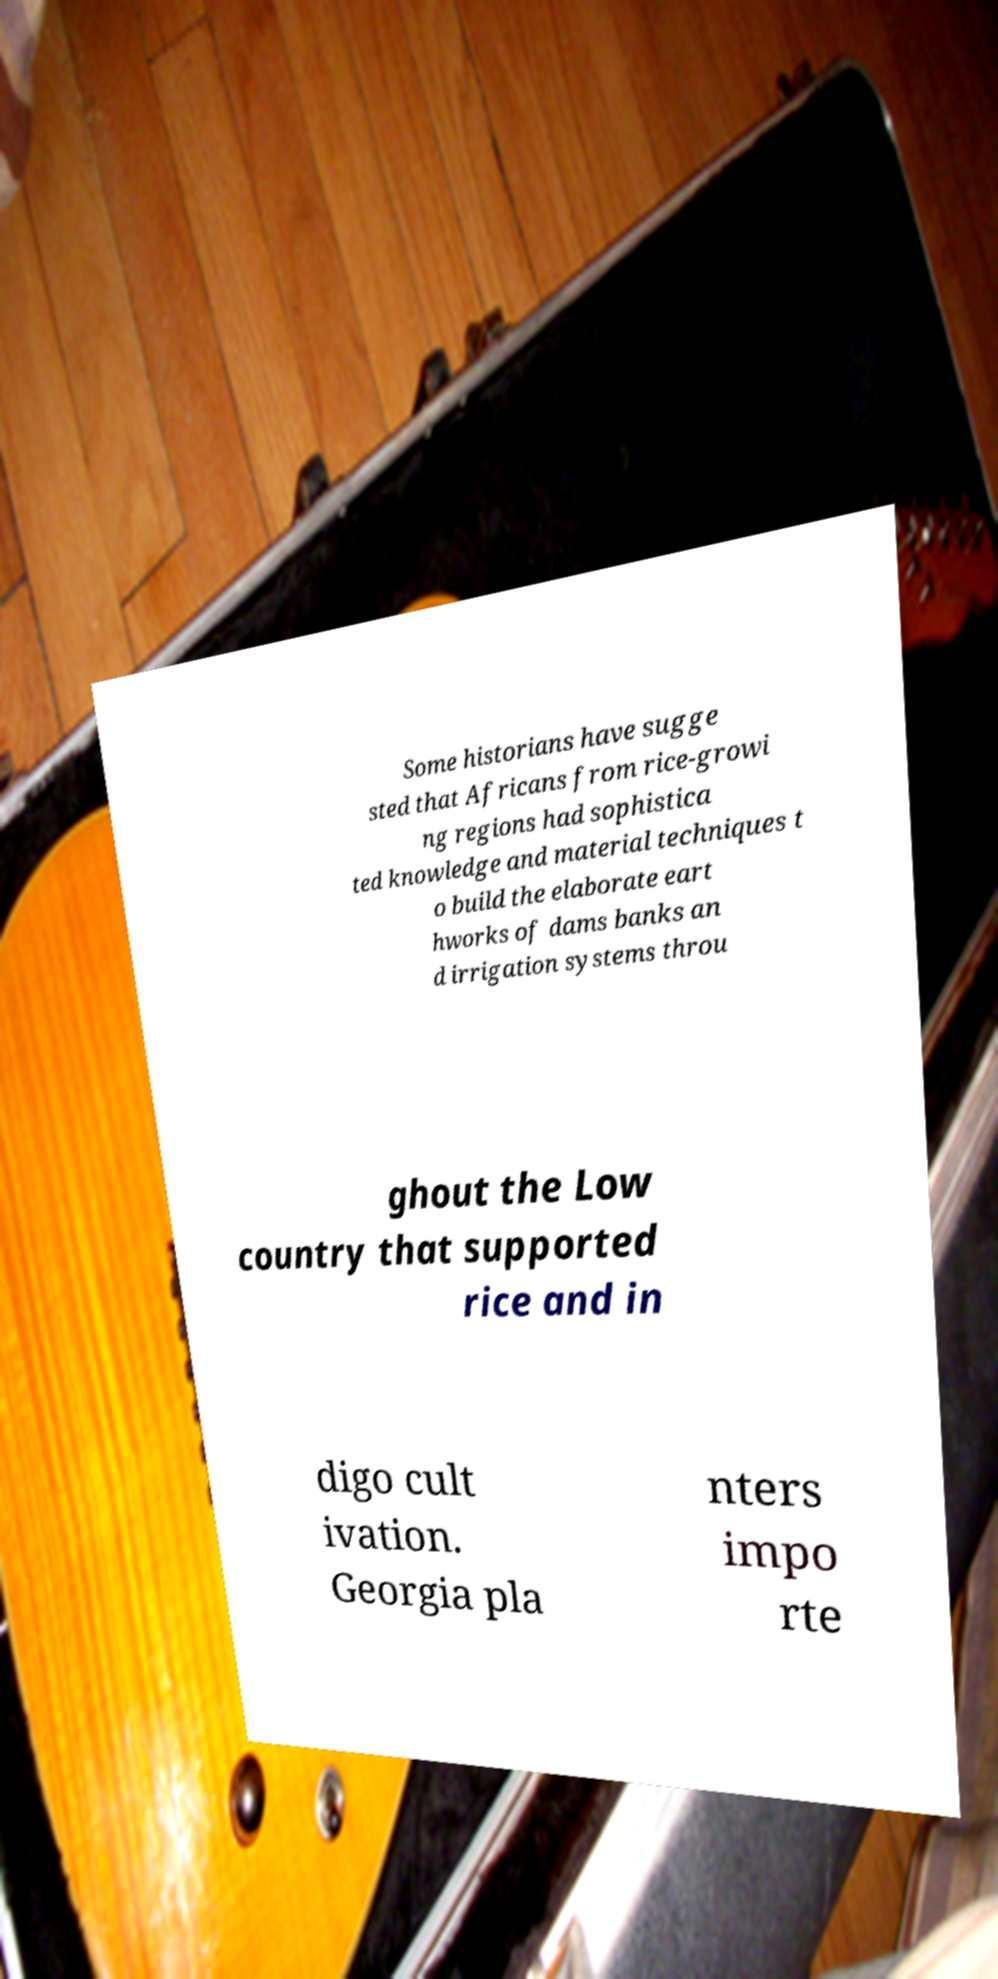Could you extract and type out the text from this image? Some historians have sugge sted that Africans from rice-growi ng regions had sophistica ted knowledge and material techniques t o build the elaborate eart hworks of dams banks an d irrigation systems throu ghout the Low country that supported rice and in digo cult ivation. Georgia pla nters impo rte 